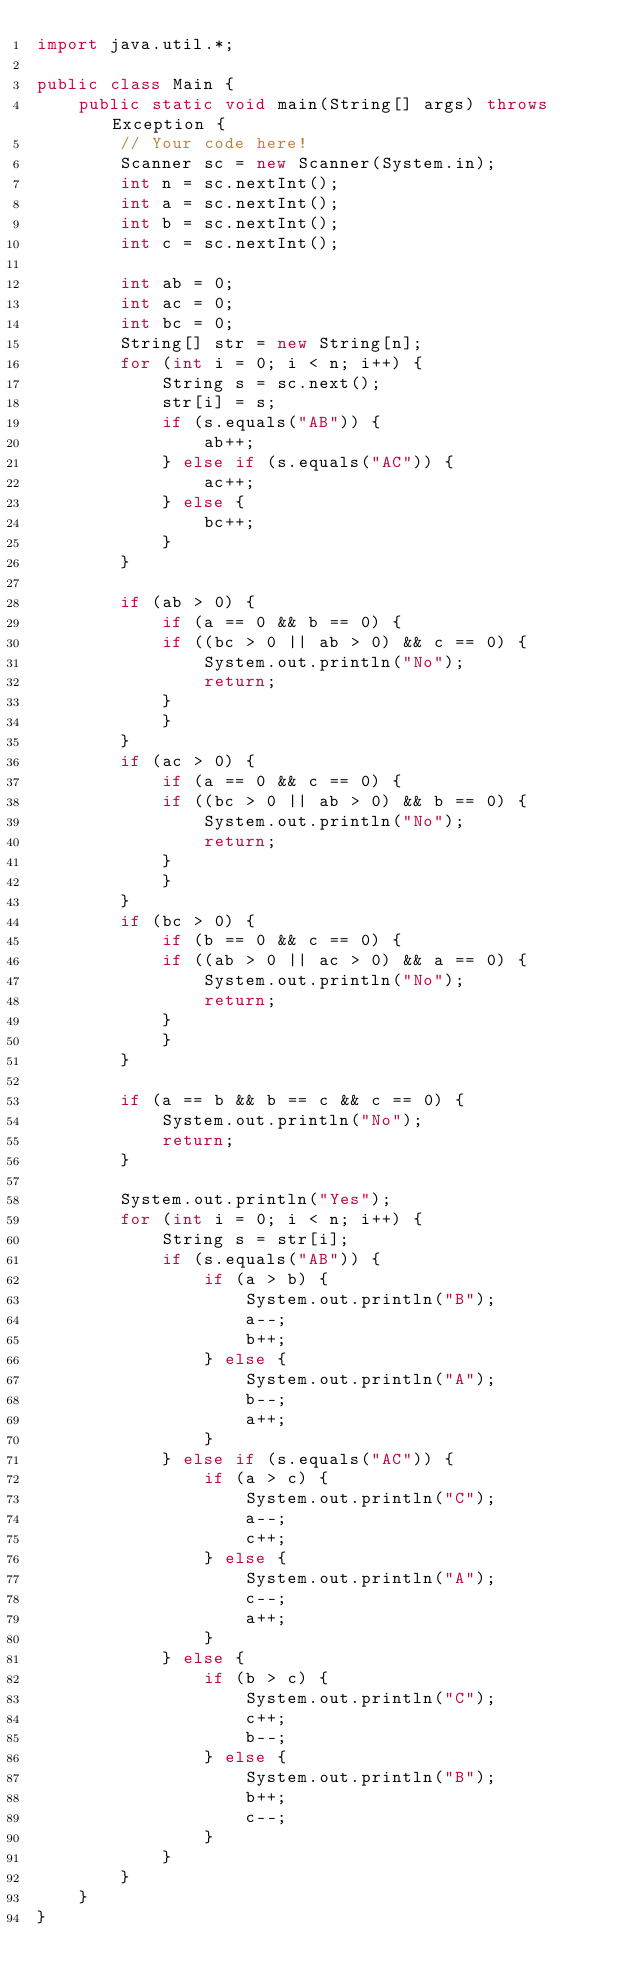Convert code to text. <code><loc_0><loc_0><loc_500><loc_500><_Java_>import java.util.*;

public class Main {
    public static void main(String[] args) throws Exception {
        // Your code here!
        Scanner sc = new Scanner(System.in);
        int n = sc.nextInt();
        int a = sc.nextInt();
        int b = sc.nextInt();
        int c = sc.nextInt();
        
        int ab = 0;
        int ac = 0;
        int bc = 0;
        String[] str = new String[n];
        for (int i = 0; i < n; i++) {
            String s = sc.next();
            str[i] = s;
            if (s.equals("AB")) {
                ab++;
            } else if (s.equals("AC")) {
                ac++;
            } else {
                bc++;
            }
        }
        
        if (ab > 0) {
            if (a == 0 && b == 0) {
            if ((bc > 0 || ab > 0) && c == 0) {
                System.out.println("No");
                return;
            }
            }
        }
        if (ac > 0) {
            if (a == 0 && c == 0) {
            if ((bc > 0 || ab > 0) && b == 0) {
                System.out.println("No");
                return;
            }
            }
        }
        if (bc > 0) {
            if (b == 0 && c == 0) {
            if ((ab > 0 || ac > 0) && a == 0) {
                System.out.println("No");
                return;
            }
            }
        }
        
        if (a == b && b == c && c == 0) {
            System.out.println("No");
            return;
        }
        
        System.out.println("Yes");
        for (int i = 0; i < n; i++) {
            String s = str[i];
            if (s.equals("AB")) {
                if (a > b) {
                    System.out.println("B");
                    a--;
                    b++;
                } else {
                    System.out.println("A");
                    b--;
                    a++;
                }
            } else if (s.equals("AC")) {
                if (a > c) {
                    System.out.println("C");
                    a--;
                    c++;
                } else {
                    System.out.println("A");
                    c--;
                    a++;
                }
            } else {
                if (b > c) {
                    System.out.println("C");
                    c++;
                    b--;
                } else {
                    System.out.println("B");
                    b++;
                    c--;
                }
            }
        }
    }
}
</code> 